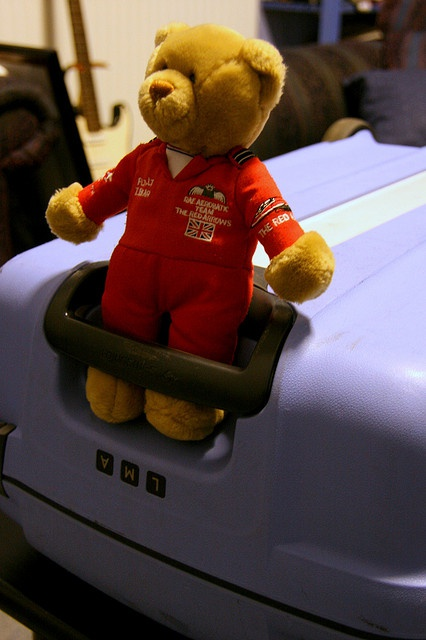Describe the objects in this image and their specific colors. I can see suitcase in tan, black, lavender, and gray tones and teddy bear in tan, maroon, black, olive, and orange tones in this image. 